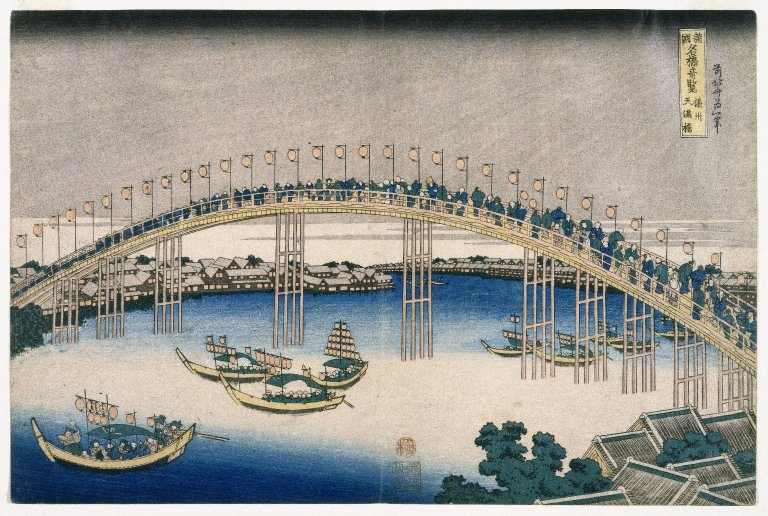Can you tell me more about this form of art? Why is it significant? Ukiyo-e, which translates to 'pictures of the floating world,' is a genre of Japanese art that flourished from the 17th through the 19th centuries. It is significant for its vibrant portrayal of daily life, landscapes, and history, often featuring high levels of detail and distinctive color palettes. The art form utilized woodblock printing techniques, which was a major development that allowed for mass production of prints, helping spread the cultural and artistic styles widely amongst the populace during Edo period Japan. 